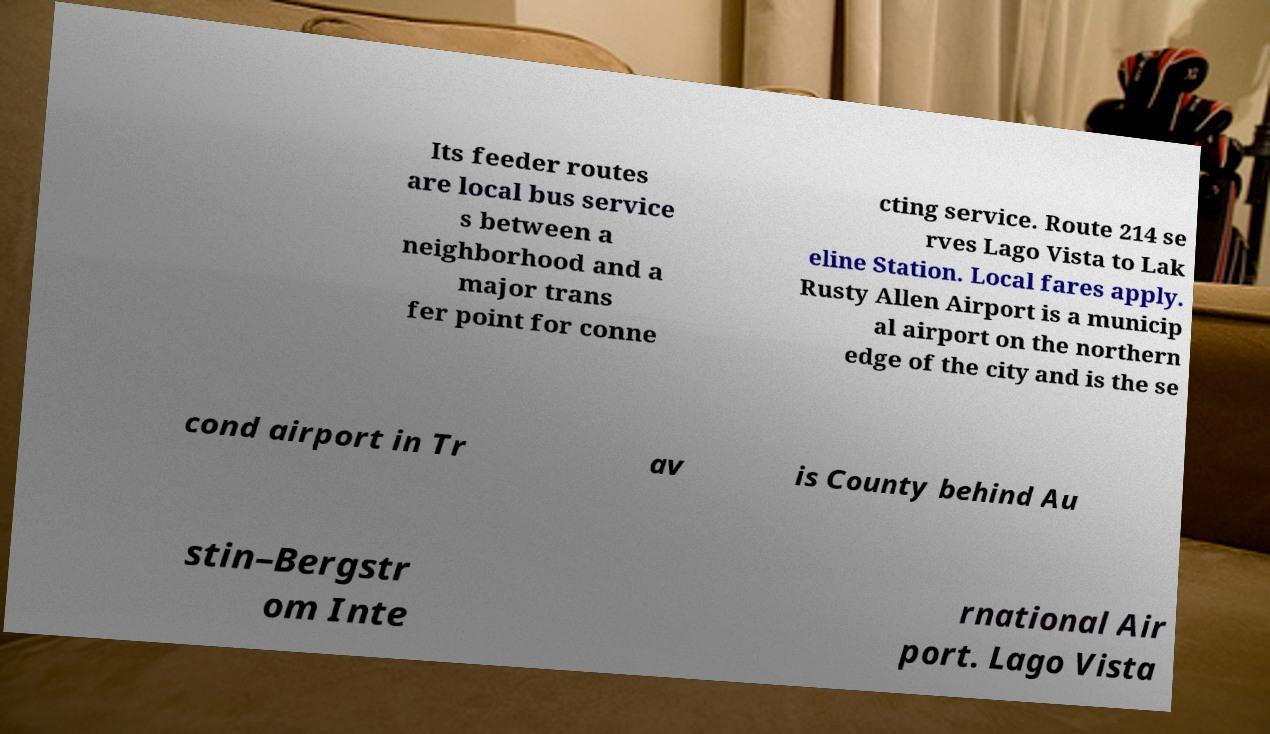There's text embedded in this image that I need extracted. Can you transcribe it verbatim? Its feeder routes are local bus service s between a neighborhood and a major trans fer point for conne cting service. Route 214 se rves Lago Vista to Lak eline Station. Local fares apply. Rusty Allen Airport is a municip al airport on the northern edge of the city and is the se cond airport in Tr av is County behind Au stin–Bergstr om Inte rnational Air port. Lago Vista 